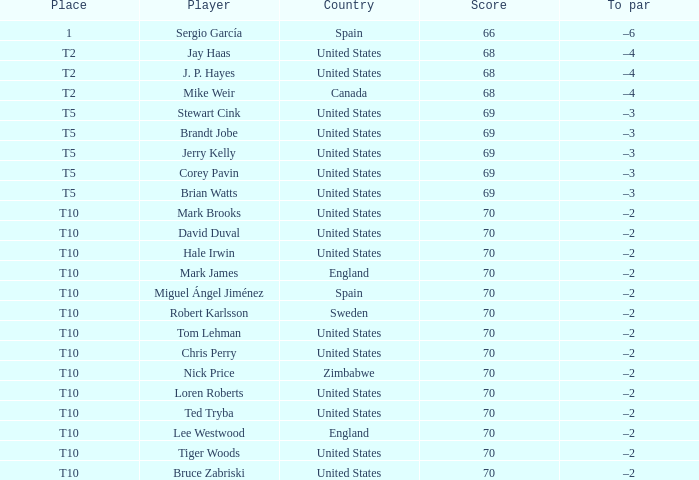Which player had a score of 70? Mark Brooks, David Duval, Hale Irwin, Mark James, Miguel Ángel Jiménez, Robert Karlsson, Tom Lehman, Chris Perry, Nick Price, Loren Roberts, Ted Tryba, Lee Westwood, Tiger Woods, Bruce Zabriski. 